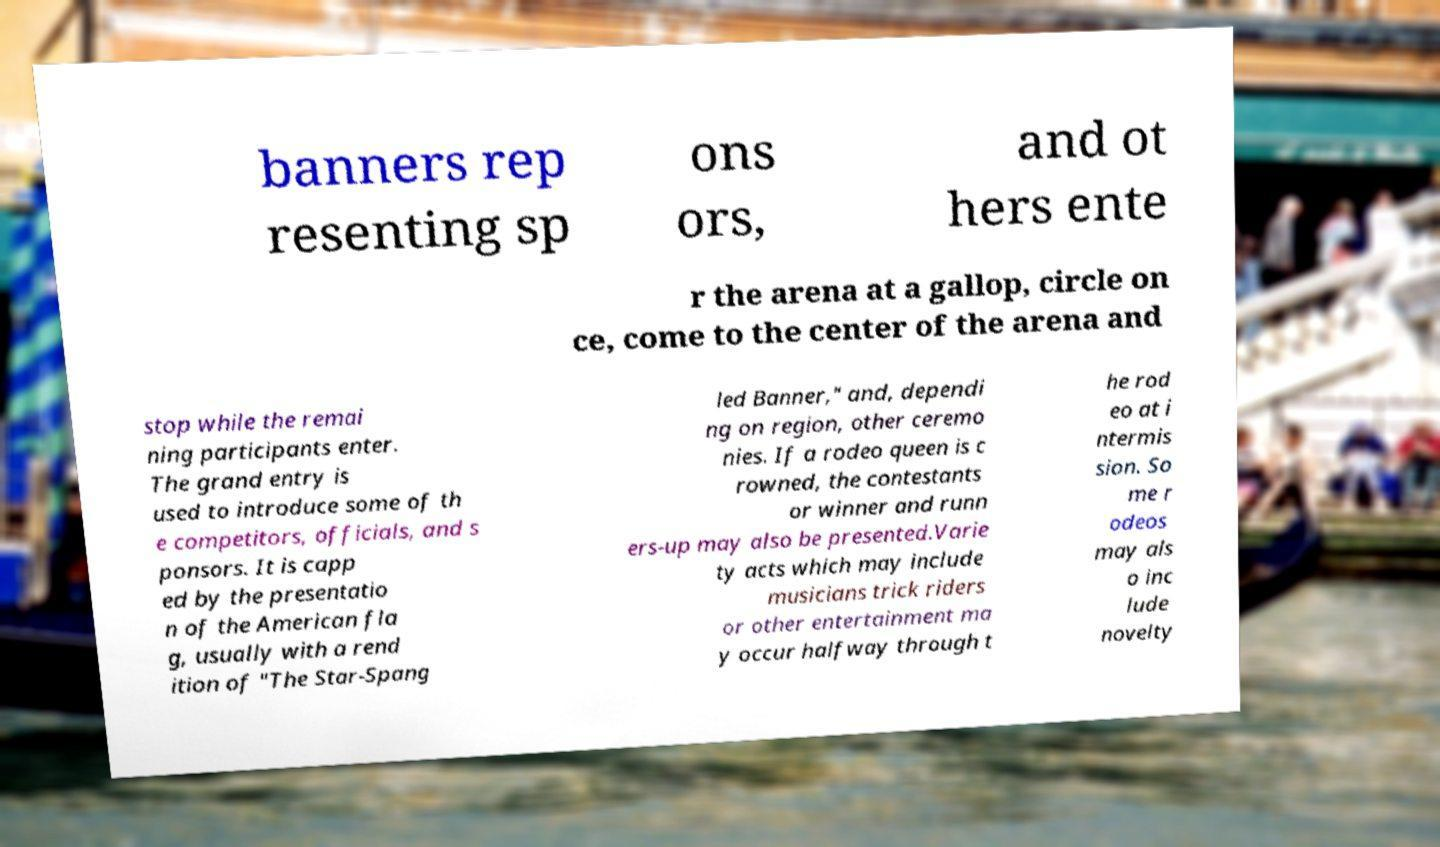What messages or text are displayed in this image? I need them in a readable, typed format. banners rep resenting sp ons ors, and ot hers ente r the arena at a gallop, circle on ce, come to the center of the arena and stop while the remai ning participants enter. The grand entry is used to introduce some of th e competitors, officials, and s ponsors. It is capp ed by the presentatio n of the American fla g, usually with a rend ition of "The Star-Spang led Banner," and, dependi ng on region, other ceremo nies. If a rodeo queen is c rowned, the contestants or winner and runn ers-up may also be presented.Varie ty acts which may include musicians trick riders or other entertainment ma y occur halfway through t he rod eo at i ntermis sion. So me r odeos may als o inc lude novelty 